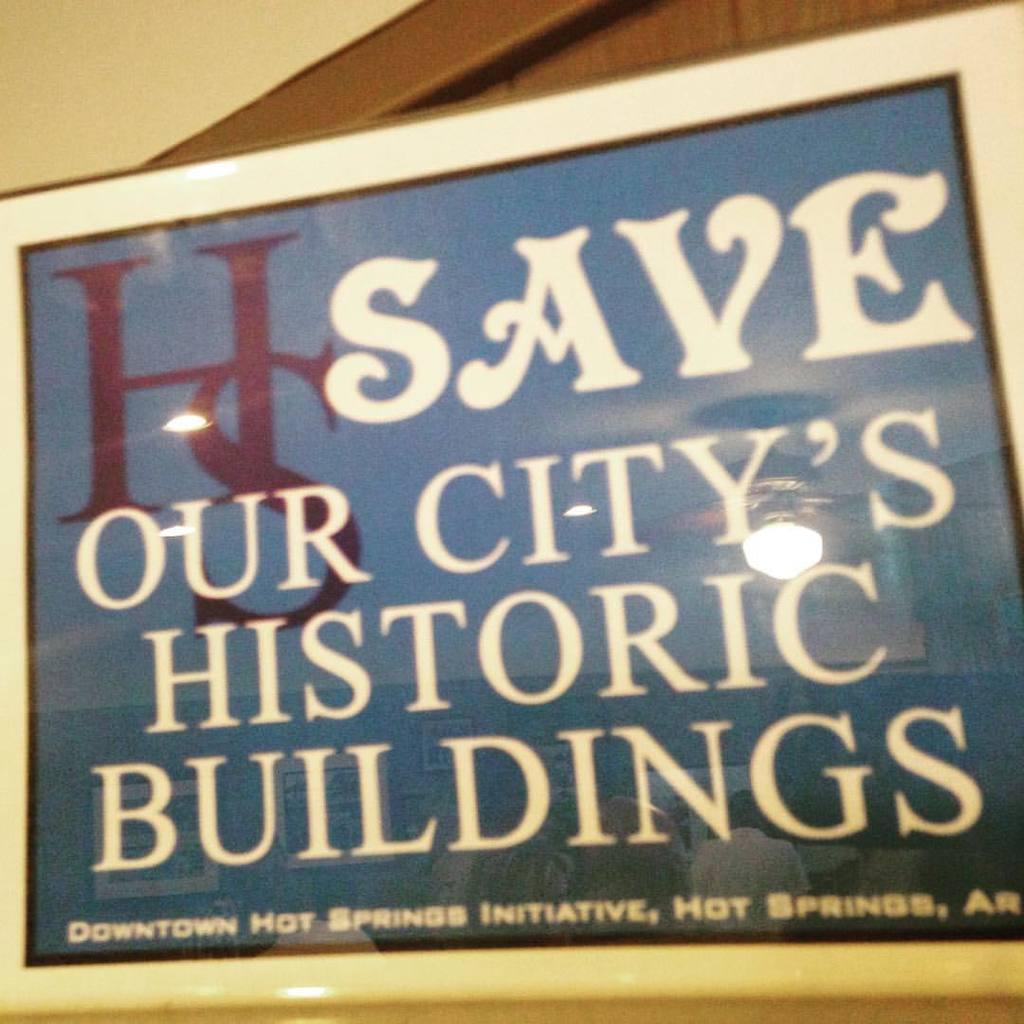What does the sign want you to save?
Make the answer very short. Our city's historic buildings. What is the name of the initiative?
Your response must be concise. Downtown hot springs initiative. 